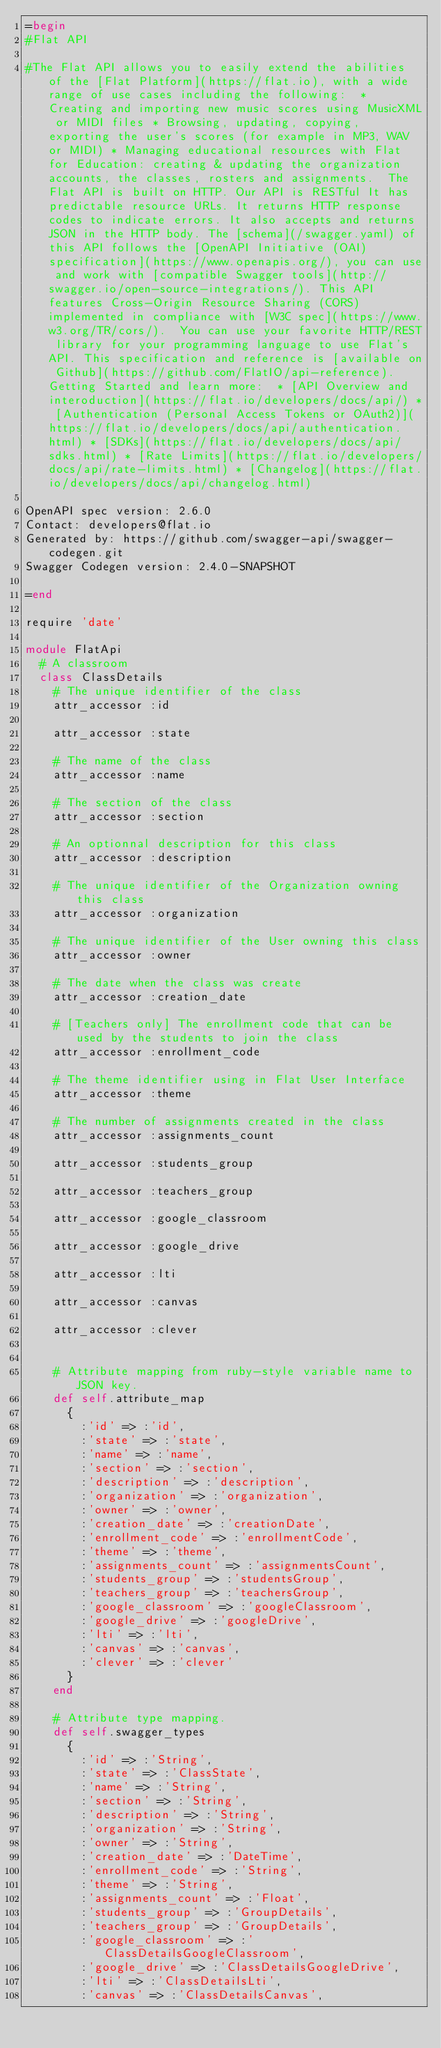<code> <loc_0><loc_0><loc_500><loc_500><_Ruby_>=begin
#Flat API

#The Flat API allows you to easily extend the abilities of the [Flat Platform](https://flat.io), with a wide range of use cases including the following:  * Creating and importing new music scores using MusicXML or MIDI files * Browsing, updating, copying, exporting the user's scores (for example in MP3, WAV or MIDI) * Managing educational resources with Flat for Education: creating & updating the organization accounts, the classes, rosters and assignments.  The Flat API is built on HTTP. Our API is RESTful It has predictable resource URLs. It returns HTTP response codes to indicate errors. It also accepts and returns JSON in the HTTP body. The [schema](/swagger.yaml) of this API follows the [OpenAPI Initiative (OAI) specification](https://www.openapis.org/), you can use and work with [compatible Swagger tools](http://swagger.io/open-source-integrations/). This API features Cross-Origin Resource Sharing (CORS) implemented in compliance with [W3C spec](https://www.w3.org/TR/cors/).  You can use your favorite HTTP/REST library for your programming language to use Flat's API. This specification and reference is [available on Github](https://github.com/FlatIO/api-reference).  Getting Started and learn more:  * [API Overview and interoduction](https://flat.io/developers/docs/api/) * [Authentication (Personal Access Tokens or OAuth2)](https://flat.io/developers/docs/api/authentication.html) * [SDKs](https://flat.io/developers/docs/api/sdks.html) * [Rate Limits](https://flat.io/developers/docs/api/rate-limits.html) * [Changelog](https://flat.io/developers/docs/api/changelog.html) 

OpenAPI spec version: 2.6.0
Contact: developers@flat.io
Generated by: https://github.com/swagger-api/swagger-codegen.git
Swagger Codegen version: 2.4.0-SNAPSHOT

=end

require 'date'

module FlatApi
  # A classroom
  class ClassDetails
    # The unique identifier of the class
    attr_accessor :id

    attr_accessor :state

    # The name of the class
    attr_accessor :name

    # The section of the class
    attr_accessor :section

    # An optionnal description for this class
    attr_accessor :description

    # The unique identifier of the Organization owning this class
    attr_accessor :organization

    # The unique identifier of the User owning this class
    attr_accessor :owner

    # The date when the class was create
    attr_accessor :creation_date

    # [Teachers only] The enrollment code that can be used by the students to join the class 
    attr_accessor :enrollment_code

    # The theme identifier using in Flat User Interface
    attr_accessor :theme

    # The number of assignments created in the class
    attr_accessor :assignments_count

    attr_accessor :students_group

    attr_accessor :teachers_group

    attr_accessor :google_classroom

    attr_accessor :google_drive

    attr_accessor :lti

    attr_accessor :canvas

    attr_accessor :clever


    # Attribute mapping from ruby-style variable name to JSON key.
    def self.attribute_map
      {
        :'id' => :'id',
        :'state' => :'state',
        :'name' => :'name',
        :'section' => :'section',
        :'description' => :'description',
        :'organization' => :'organization',
        :'owner' => :'owner',
        :'creation_date' => :'creationDate',
        :'enrollment_code' => :'enrollmentCode',
        :'theme' => :'theme',
        :'assignments_count' => :'assignmentsCount',
        :'students_group' => :'studentsGroup',
        :'teachers_group' => :'teachersGroup',
        :'google_classroom' => :'googleClassroom',
        :'google_drive' => :'googleDrive',
        :'lti' => :'lti',
        :'canvas' => :'canvas',
        :'clever' => :'clever'
      }
    end

    # Attribute type mapping.
    def self.swagger_types
      {
        :'id' => :'String',
        :'state' => :'ClassState',
        :'name' => :'String',
        :'section' => :'String',
        :'description' => :'String',
        :'organization' => :'String',
        :'owner' => :'String',
        :'creation_date' => :'DateTime',
        :'enrollment_code' => :'String',
        :'theme' => :'String',
        :'assignments_count' => :'Float',
        :'students_group' => :'GroupDetails',
        :'teachers_group' => :'GroupDetails',
        :'google_classroom' => :'ClassDetailsGoogleClassroom',
        :'google_drive' => :'ClassDetailsGoogleDrive',
        :'lti' => :'ClassDetailsLti',
        :'canvas' => :'ClassDetailsCanvas',</code> 